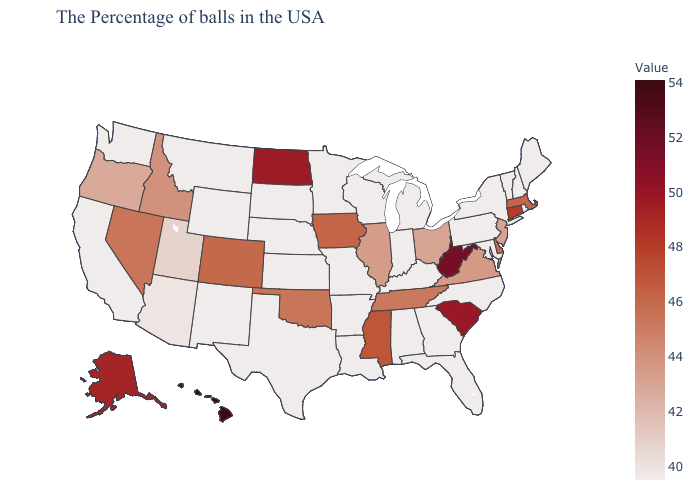Which states have the lowest value in the South?
Short answer required. Maryland, North Carolina, Florida, Georgia, Kentucky, Alabama, Louisiana, Arkansas, Texas. Does New Mexico have the highest value in the West?
Short answer required. No. Is the legend a continuous bar?
Give a very brief answer. Yes. Among the states that border Georgia , does Tennessee have the highest value?
Be succinct. No. Does Hawaii have the highest value in the West?
Write a very short answer. Yes. Among the states that border New Mexico , does Texas have the lowest value?
Give a very brief answer. Yes. Does Iowa have the lowest value in the USA?
Be succinct. No. 